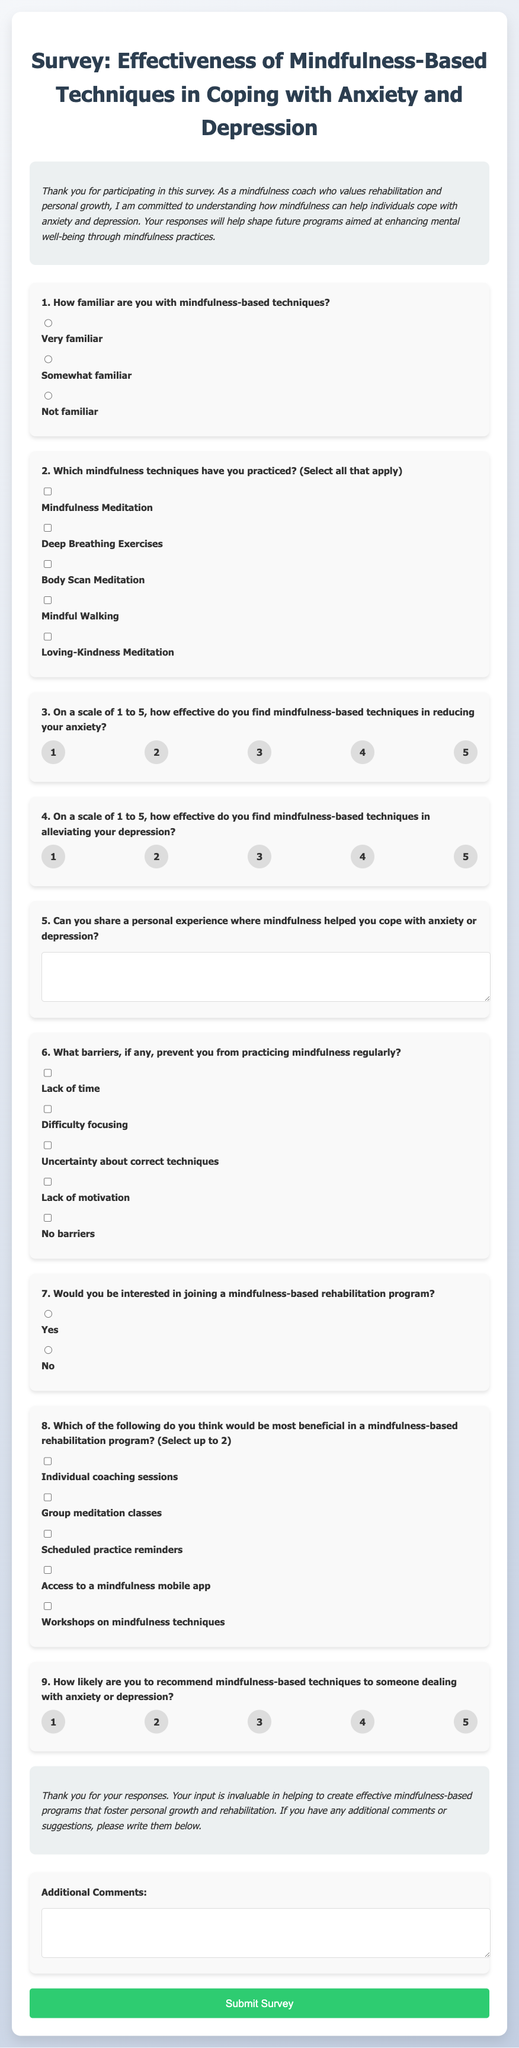What is the title of the survey? The title of the survey is prominently displayed at the top of the document.
Answer: Effectiveness of Mindfulness-Based Techniques in Coping with Anxiety and Depression What question number asks about barriers to practicing mindfulness? The document lists questions in a sequential format, which can be referenced by their numbering.
Answer: 6 How many mindfulness techniques can participants select in question 2? The question allows participants to select multiple options, which is indicated by the phrasing "Select all that apply."
Answer: All that apply On a scale of 1 to 5, how many response options are provided for the anxiety effectiveness rating? The document visually presents the response options as radio buttons with clear numbering.
Answer: 5 What specific technique is not listed as an option in question 2? The question lists specific techniques, and to determine which one is missing, one can compare with commonly known mindfulness techniques.
Answer: (Any specific technique not listed in options, such as "Yoga".) What is the maximum number of beneficial options a participant can select in question 8? The phrasing "Select up to 2" directly informs how many options can be chosen.
Answer: 2 What type of comment section follows the conclusion? The conclusion of the survey is designed to gather further input from respondents, as indicated by the last question.
Answer: Additional Comments Is "Lack of motivation" included in the barriers listed? The document specifically names barriers, and one must look for that phrase among the listed options.
Answer: Yes What color scheme is used in the document's background? The document describes a gradient that reflects the overall aesthetic, which can be inferred from the stylesheet.
Answer: Gradient from light grey to light blue 